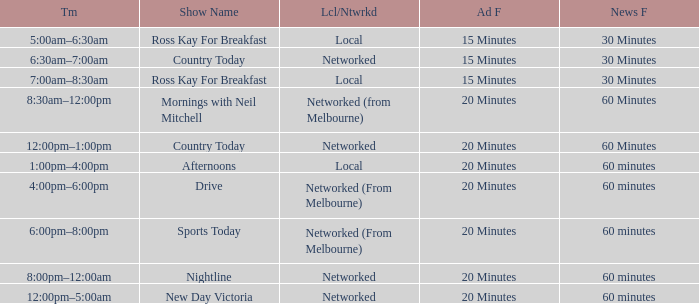What Ad Freq has a News Freq of 60 minutes, and a Local/Networked of local? 20 Minutes. 